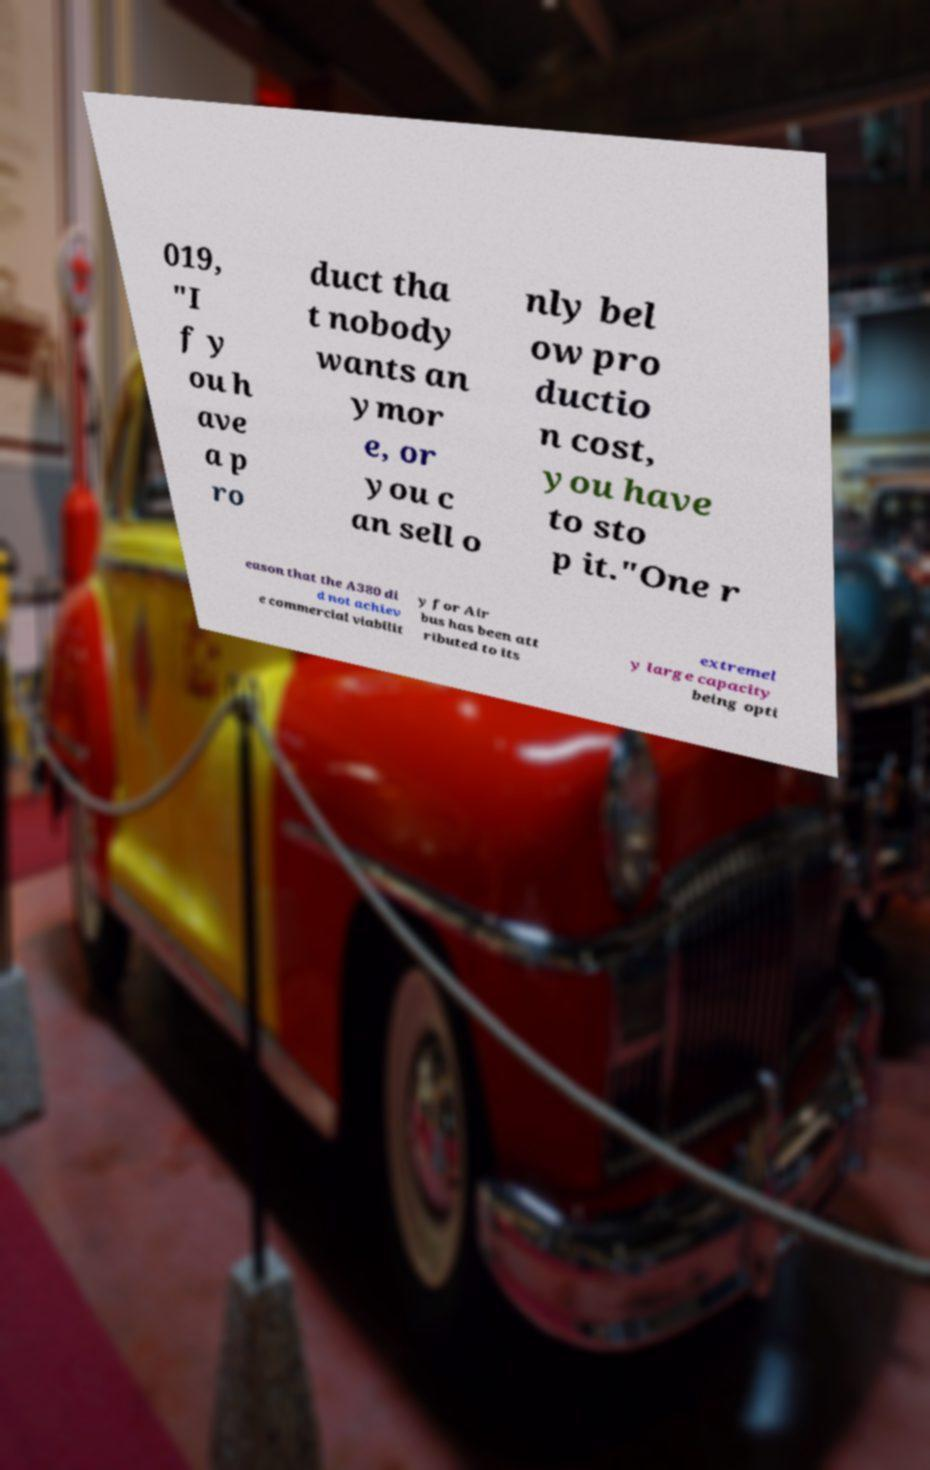Can you read and provide the text displayed in the image?This photo seems to have some interesting text. Can you extract and type it out for me? 019, "I f y ou h ave a p ro duct tha t nobody wants an ymor e, or you c an sell o nly bel ow pro ductio n cost, you have to sto p it."One r eason that the A380 di d not achiev e commercial viabilit y for Air bus has been att ributed to its extremel y large capacity being opti 